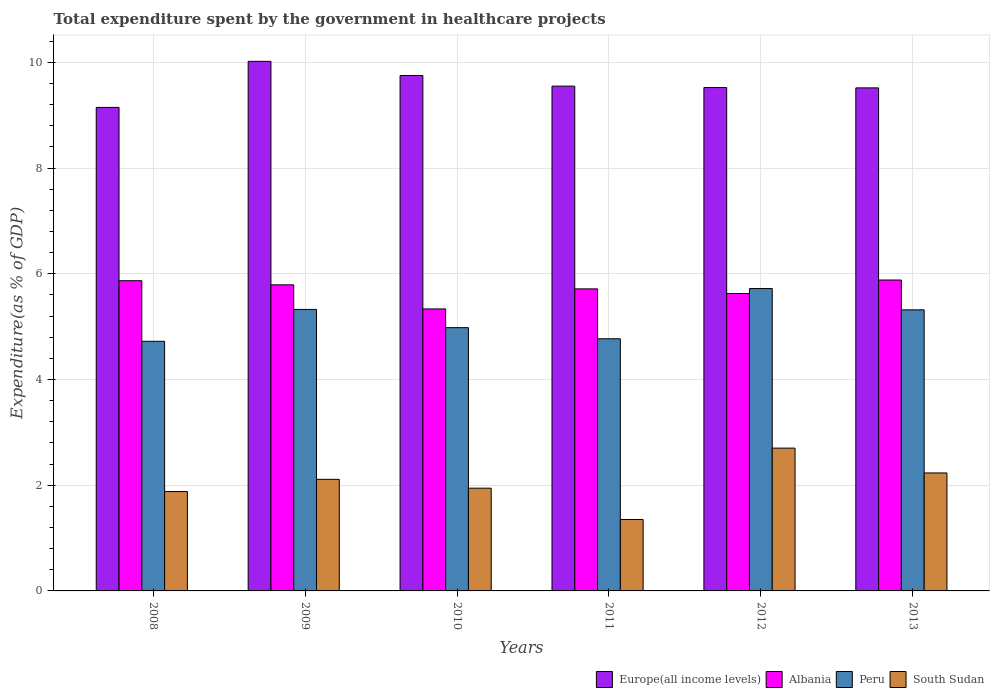Are the number of bars per tick equal to the number of legend labels?
Your response must be concise. Yes. Are the number of bars on each tick of the X-axis equal?
Ensure brevity in your answer.  Yes. How many bars are there on the 2nd tick from the left?
Offer a very short reply. 4. What is the total expenditure spent by the government in healthcare projects in Peru in 2011?
Provide a short and direct response. 4.77. Across all years, what is the maximum total expenditure spent by the government in healthcare projects in Peru?
Your answer should be very brief. 5.72. Across all years, what is the minimum total expenditure spent by the government in healthcare projects in Albania?
Make the answer very short. 5.34. In which year was the total expenditure spent by the government in healthcare projects in Peru maximum?
Your answer should be very brief. 2012. What is the total total expenditure spent by the government in healthcare projects in Albania in the graph?
Ensure brevity in your answer.  34.22. What is the difference between the total expenditure spent by the government in healthcare projects in South Sudan in 2008 and that in 2011?
Offer a terse response. 0.53. What is the difference between the total expenditure spent by the government in healthcare projects in South Sudan in 2008 and the total expenditure spent by the government in healthcare projects in Albania in 2009?
Make the answer very short. -3.91. What is the average total expenditure spent by the government in healthcare projects in Europe(all income levels) per year?
Keep it short and to the point. 9.59. In the year 2012, what is the difference between the total expenditure spent by the government in healthcare projects in Peru and total expenditure spent by the government in healthcare projects in Europe(all income levels)?
Give a very brief answer. -3.8. In how many years, is the total expenditure spent by the government in healthcare projects in Albania greater than 6.8 %?
Your answer should be very brief. 0. What is the ratio of the total expenditure spent by the government in healthcare projects in Europe(all income levels) in 2011 to that in 2013?
Make the answer very short. 1. Is the difference between the total expenditure spent by the government in healthcare projects in Peru in 2008 and 2011 greater than the difference between the total expenditure spent by the government in healthcare projects in Europe(all income levels) in 2008 and 2011?
Your response must be concise. Yes. What is the difference between the highest and the second highest total expenditure spent by the government in healthcare projects in Europe(all income levels)?
Offer a terse response. 0.27. What is the difference between the highest and the lowest total expenditure spent by the government in healthcare projects in Peru?
Keep it short and to the point. 1. Is the sum of the total expenditure spent by the government in healthcare projects in Albania in 2011 and 2012 greater than the maximum total expenditure spent by the government in healthcare projects in Europe(all income levels) across all years?
Your answer should be compact. Yes. What does the 2nd bar from the left in 2011 represents?
Keep it short and to the point. Albania. What does the 4th bar from the right in 2010 represents?
Provide a succinct answer. Europe(all income levels). How many bars are there?
Offer a very short reply. 24. What is the difference between two consecutive major ticks on the Y-axis?
Ensure brevity in your answer.  2. Are the values on the major ticks of Y-axis written in scientific E-notation?
Your response must be concise. No. Where does the legend appear in the graph?
Ensure brevity in your answer.  Bottom right. How are the legend labels stacked?
Your answer should be compact. Horizontal. What is the title of the graph?
Give a very brief answer. Total expenditure spent by the government in healthcare projects. What is the label or title of the X-axis?
Ensure brevity in your answer.  Years. What is the label or title of the Y-axis?
Offer a terse response. Expenditure(as % of GDP). What is the Expenditure(as % of GDP) of Europe(all income levels) in 2008?
Make the answer very short. 9.15. What is the Expenditure(as % of GDP) in Albania in 2008?
Your answer should be very brief. 5.87. What is the Expenditure(as % of GDP) in Peru in 2008?
Your answer should be compact. 4.72. What is the Expenditure(as % of GDP) in South Sudan in 2008?
Ensure brevity in your answer.  1.88. What is the Expenditure(as % of GDP) of Europe(all income levels) in 2009?
Your response must be concise. 10.02. What is the Expenditure(as % of GDP) in Albania in 2009?
Keep it short and to the point. 5.79. What is the Expenditure(as % of GDP) of Peru in 2009?
Your answer should be compact. 5.33. What is the Expenditure(as % of GDP) in South Sudan in 2009?
Make the answer very short. 2.11. What is the Expenditure(as % of GDP) of Europe(all income levels) in 2010?
Make the answer very short. 9.75. What is the Expenditure(as % of GDP) in Albania in 2010?
Your response must be concise. 5.34. What is the Expenditure(as % of GDP) of Peru in 2010?
Offer a very short reply. 4.98. What is the Expenditure(as % of GDP) of South Sudan in 2010?
Your response must be concise. 1.94. What is the Expenditure(as % of GDP) in Europe(all income levels) in 2011?
Ensure brevity in your answer.  9.55. What is the Expenditure(as % of GDP) of Albania in 2011?
Offer a very short reply. 5.71. What is the Expenditure(as % of GDP) of Peru in 2011?
Your answer should be very brief. 4.77. What is the Expenditure(as % of GDP) in South Sudan in 2011?
Offer a terse response. 1.35. What is the Expenditure(as % of GDP) of Europe(all income levels) in 2012?
Ensure brevity in your answer.  9.52. What is the Expenditure(as % of GDP) of Albania in 2012?
Give a very brief answer. 5.63. What is the Expenditure(as % of GDP) in Peru in 2012?
Provide a succinct answer. 5.72. What is the Expenditure(as % of GDP) in South Sudan in 2012?
Your answer should be very brief. 2.7. What is the Expenditure(as % of GDP) in Europe(all income levels) in 2013?
Provide a succinct answer. 9.52. What is the Expenditure(as % of GDP) in Albania in 2013?
Offer a very short reply. 5.88. What is the Expenditure(as % of GDP) of Peru in 2013?
Make the answer very short. 5.32. What is the Expenditure(as % of GDP) of South Sudan in 2013?
Provide a short and direct response. 2.23. Across all years, what is the maximum Expenditure(as % of GDP) in Europe(all income levels)?
Your answer should be compact. 10.02. Across all years, what is the maximum Expenditure(as % of GDP) in Albania?
Keep it short and to the point. 5.88. Across all years, what is the maximum Expenditure(as % of GDP) in Peru?
Ensure brevity in your answer.  5.72. Across all years, what is the maximum Expenditure(as % of GDP) in South Sudan?
Provide a short and direct response. 2.7. Across all years, what is the minimum Expenditure(as % of GDP) in Europe(all income levels)?
Your answer should be very brief. 9.15. Across all years, what is the minimum Expenditure(as % of GDP) of Albania?
Ensure brevity in your answer.  5.34. Across all years, what is the minimum Expenditure(as % of GDP) of Peru?
Provide a short and direct response. 4.72. Across all years, what is the minimum Expenditure(as % of GDP) in South Sudan?
Offer a terse response. 1.35. What is the total Expenditure(as % of GDP) of Europe(all income levels) in the graph?
Your answer should be very brief. 57.51. What is the total Expenditure(as % of GDP) of Albania in the graph?
Ensure brevity in your answer.  34.22. What is the total Expenditure(as % of GDP) in Peru in the graph?
Your answer should be compact. 30.84. What is the total Expenditure(as % of GDP) in South Sudan in the graph?
Your answer should be very brief. 12.22. What is the difference between the Expenditure(as % of GDP) in Europe(all income levels) in 2008 and that in 2009?
Provide a short and direct response. -0.87. What is the difference between the Expenditure(as % of GDP) of Albania in 2008 and that in 2009?
Offer a terse response. 0.08. What is the difference between the Expenditure(as % of GDP) of Peru in 2008 and that in 2009?
Keep it short and to the point. -0.6. What is the difference between the Expenditure(as % of GDP) in South Sudan in 2008 and that in 2009?
Give a very brief answer. -0.23. What is the difference between the Expenditure(as % of GDP) in Europe(all income levels) in 2008 and that in 2010?
Ensure brevity in your answer.  -0.6. What is the difference between the Expenditure(as % of GDP) of Albania in 2008 and that in 2010?
Keep it short and to the point. 0.53. What is the difference between the Expenditure(as % of GDP) of Peru in 2008 and that in 2010?
Keep it short and to the point. -0.26. What is the difference between the Expenditure(as % of GDP) in South Sudan in 2008 and that in 2010?
Provide a succinct answer. -0.06. What is the difference between the Expenditure(as % of GDP) in Europe(all income levels) in 2008 and that in 2011?
Ensure brevity in your answer.  -0.4. What is the difference between the Expenditure(as % of GDP) of Albania in 2008 and that in 2011?
Make the answer very short. 0.15. What is the difference between the Expenditure(as % of GDP) in Peru in 2008 and that in 2011?
Offer a terse response. -0.05. What is the difference between the Expenditure(as % of GDP) of South Sudan in 2008 and that in 2011?
Your response must be concise. 0.53. What is the difference between the Expenditure(as % of GDP) in Europe(all income levels) in 2008 and that in 2012?
Provide a short and direct response. -0.38. What is the difference between the Expenditure(as % of GDP) in Albania in 2008 and that in 2012?
Offer a terse response. 0.24. What is the difference between the Expenditure(as % of GDP) in Peru in 2008 and that in 2012?
Your response must be concise. -1. What is the difference between the Expenditure(as % of GDP) in South Sudan in 2008 and that in 2012?
Make the answer very short. -0.82. What is the difference between the Expenditure(as % of GDP) of Europe(all income levels) in 2008 and that in 2013?
Offer a very short reply. -0.37. What is the difference between the Expenditure(as % of GDP) in Albania in 2008 and that in 2013?
Keep it short and to the point. -0.01. What is the difference between the Expenditure(as % of GDP) of Peru in 2008 and that in 2013?
Keep it short and to the point. -0.59. What is the difference between the Expenditure(as % of GDP) in South Sudan in 2008 and that in 2013?
Offer a very short reply. -0.35. What is the difference between the Expenditure(as % of GDP) of Europe(all income levels) in 2009 and that in 2010?
Ensure brevity in your answer.  0.27. What is the difference between the Expenditure(as % of GDP) of Albania in 2009 and that in 2010?
Ensure brevity in your answer.  0.46. What is the difference between the Expenditure(as % of GDP) of Peru in 2009 and that in 2010?
Your answer should be very brief. 0.34. What is the difference between the Expenditure(as % of GDP) of South Sudan in 2009 and that in 2010?
Ensure brevity in your answer.  0.17. What is the difference between the Expenditure(as % of GDP) in Europe(all income levels) in 2009 and that in 2011?
Offer a terse response. 0.47. What is the difference between the Expenditure(as % of GDP) in Albania in 2009 and that in 2011?
Keep it short and to the point. 0.08. What is the difference between the Expenditure(as % of GDP) in Peru in 2009 and that in 2011?
Give a very brief answer. 0.56. What is the difference between the Expenditure(as % of GDP) of South Sudan in 2009 and that in 2011?
Your answer should be very brief. 0.76. What is the difference between the Expenditure(as % of GDP) of Europe(all income levels) in 2009 and that in 2012?
Give a very brief answer. 0.5. What is the difference between the Expenditure(as % of GDP) in Albania in 2009 and that in 2012?
Give a very brief answer. 0.16. What is the difference between the Expenditure(as % of GDP) of Peru in 2009 and that in 2012?
Your answer should be compact. -0.4. What is the difference between the Expenditure(as % of GDP) in South Sudan in 2009 and that in 2012?
Your response must be concise. -0.59. What is the difference between the Expenditure(as % of GDP) of Europe(all income levels) in 2009 and that in 2013?
Make the answer very short. 0.5. What is the difference between the Expenditure(as % of GDP) in Albania in 2009 and that in 2013?
Keep it short and to the point. -0.09. What is the difference between the Expenditure(as % of GDP) of Peru in 2009 and that in 2013?
Offer a terse response. 0.01. What is the difference between the Expenditure(as % of GDP) in South Sudan in 2009 and that in 2013?
Provide a succinct answer. -0.12. What is the difference between the Expenditure(as % of GDP) of Europe(all income levels) in 2010 and that in 2011?
Give a very brief answer. 0.2. What is the difference between the Expenditure(as % of GDP) of Albania in 2010 and that in 2011?
Your answer should be very brief. -0.38. What is the difference between the Expenditure(as % of GDP) in Peru in 2010 and that in 2011?
Offer a very short reply. 0.21. What is the difference between the Expenditure(as % of GDP) in South Sudan in 2010 and that in 2011?
Keep it short and to the point. 0.59. What is the difference between the Expenditure(as % of GDP) in Europe(all income levels) in 2010 and that in 2012?
Your response must be concise. 0.23. What is the difference between the Expenditure(as % of GDP) in Albania in 2010 and that in 2012?
Make the answer very short. -0.29. What is the difference between the Expenditure(as % of GDP) in Peru in 2010 and that in 2012?
Give a very brief answer. -0.74. What is the difference between the Expenditure(as % of GDP) in South Sudan in 2010 and that in 2012?
Your answer should be very brief. -0.76. What is the difference between the Expenditure(as % of GDP) of Europe(all income levels) in 2010 and that in 2013?
Provide a succinct answer. 0.23. What is the difference between the Expenditure(as % of GDP) in Albania in 2010 and that in 2013?
Your answer should be very brief. -0.55. What is the difference between the Expenditure(as % of GDP) of Peru in 2010 and that in 2013?
Provide a short and direct response. -0.34. What is the difference between the Expenditure(as % of GDP) of South Sudan in 2010 and that in 2013?
Make the answer very short. -0.29. What is the difference between the Expenditure(as % of GDP) in Europe(all income levels) in 2011 and that in 2012?
Your answer should be very brief. 0.03. What is the difference between the Expenditure(as % of GDP) of Albania in 2011 and that in 2012?
Provide a short and direct response. 0.09. What is the difference between the Expenditure(as % of GDP) in Peru in 2011 and that in 2012?
Offer a very short reply. -0.95. What is the difference between the Expenditure(as % of GDP) in South Sudan in 2011 and that in 2012?
Keep it short and to the point. -1.35. What is the difference between the Expenditure(as % of GDP) in Europe(all income levels) in 2011 and that in 2013?
Give a very brief answer. 0.03. What is the difference between the Expenditure(as % of GDP) of Albania in 2011 and that in 2013?
Your answer should be compact. -0.17. What is the difference between the Expenditure(as % of GDP) in Peru in 2011 and that in 2013?
Your answer should be very brief. -0.55. What is the difference between the Expenditure(as % of GDP) of South Sudan in 2011 and that in 2013?
Make the answer very short. -0.88. What is the difference between the Expenditure(as % of GDP) of Europe(all income levels) in 2012 and that in 2013?
Your answer should be very brief. 0.01. What is the difference between the Expenditure(as % of GDP) of Albania in 2012 and that in 2013?
Give a very brief answer. -0.25. What is the difference between the Expenditure(as % of GDP) in Peru in 2012 and that in 2013?
Offer a terse response. 0.4. What is the difference between the Expenditure(as % of GDP) of South Sudan in 2012 and that in 2013?
Ensure brevity in your answer.  0.47. What is the difference between the Expenditure(as % of GDP) in Europe(all income levels) in 2008 and the Expenditure(as % of GDP) in Albania in 2009?
Ensure brevity in your answer.  3.36. What is the difference between the Expenditure(as % of GDP) of Europe(all income levels) in 2008 and the Expenditure(as % of GDP) of Peru in 2009?
Provide a short and direct response. 3.82. What is the difference between the Expenditure(as % of GDP) in Europe(all income levels) in 2008 and the Expenditure(as % of GDP) in South Sudan in 2009?
Keep it short and to the point. 7.04. What is the difference between the Expenditure(as % of GDP) in Albania in 2008 and the Expenditure(as % of GDP) in Peru in 2009?
Your answer should be very brief. 0.54. What is the difference between the Expenditure(as % of GDP) in Albania in 2008 and the Expenditure(as % of GDP) in South Sudan in 2009?
Give a very brief answer. 3.76. What is the difference between the Expenditure(as % of GDP) in Peru in 2008 and the Expenditure(as % of GDP) in South Sudan in 2009?
Ensure brevity in your answer.  2.61. What is the difference between the Expenditure(as % of GDP) in Europe(all income levels) in 2008 and the Expenditure(as % of GDP) in Albania in 2010?
Your answer should be very brief. 3.81. What is the difference between the Expenditure(as % of GDP) in Europe(all income levels) in 2008 and the Expenditure(as % of GDP) in Peru in 2010?
Your answer should be compact. 4.17. What is the difference between the Expenditure(as % of GDP) in Europe(all income levels) in 2008 and the Expenditure(as % of GDP) in South Sudan in 2010?
Your answer should be compact. 7.2. What is the difference between the Expenditure(as % of GDP) of Albania in 2008 and the Expenditure(as % of GDP) of Peru in 2010?
Your answer should be compact. 0.89. What is the difference between the Expenditure(as % of GDP) in Albania in 2008 and the Expenditure(as % of GDP) in South Sudan in 2010?
Offer a very short reply. 3.93. What is the difference between the Expenditure(as % of GDP) of Peru in 2008 and the Expenditure(as % of GDP) of South Sudan in 2010?
Offer a terse response. 2.78. What is the difference between the Expenditure(as % of GDP) of Europe(all income levels) in 2008 and the Expenditure(as % of GDP) of Albania in 2011?
Keep it short and to the point. 3.43. What is the difference between the Expenditure(as % of GDP) in Europe(all income levels) in 2008 and the Expenditure(as % of GDP) in Peru in 2011?
Ensure brevity in your answer.  4.38. What is the difference between the Expenditure(as % of GDP) of Europe(all income levels) in 2008 and the Expenditure(as % of GDP) of South Sudan in 2011?
Provide a succinct answer. 7.8. What is the difference between the Expenditure(as % of GDP) in Albania in 2008 and the Expenditure(as % of GDP) in Peru in 2011?
Keep it short and to the point. 1.1. What is the difference between the Expenditure(as % of GDP) in Albania in 2008 and the Expenditure(as % of GDP) in South Sudan in 2011?
Your answer should be compact. 4.52. What is the difference between the Expenditure(as % of GDP) of Peru in 2008 and the Expenditure(as % of GDP) of South Sudan in 2011?
Make the answer very short. 3.37. What is the difference between the Expenditure(as % of GDP) in Europe(all income levels) in 2008 and the Expenditure(as % of GDP) in Albania in 2012?
Your answer should be very brief. 3.52. What is the difference between the Expenditure(as % of GDP) of Europe(all income levels) in 2008 and the Expenditure(as % of GDP) of Peru in 2012?
Your answer should be compact. 3.43. What is the difference between the Expenditure(as % of GDP) in Europe(all income levels) in 2008 and the Expenditure(as % of GDP) in South Sudan in 2012?
Provide a succinct answer. 6.45. What is the difference between the Expenditure(as % of GDP) in Albania in 2008 and the Expenditure(as % of GDP) in Peru in 2012?
Offer a very short reply. 0.15. What is the difference between the Expenditure(as % of GDP) in Albania in 2008 and the Expenditure(as % of GDP) in South Sudan in 2012?
Ensure brevity in your answer.  3.17. What is the difference between the Expenditure(as % of GDP) of Peru in 2008 and the Expenditure(as % of GDP) of South Sudan in 2012?
Give a very brief answer. 2.02. What is the difference between the Expenditure(as % of GDP) of Europe(all income levels) in 2008 and the Expenditure(as % of GDP) of Albania in 2013?
Your answer should be very brief. 3.27. What is the difference between the Expenditure(as % of GDP) in Europe(all income levels) in 2008 and the Expenditure(as % of GDP) in Peru in 2013?
Provide a succinct answer. 3.83. What is the difference between the Expenditure(as % of GDP) of Europe(all income levels) in 2008 and the Expenditure(as % of GDP) of South Sudan in 2013?
Your answer should be very brief. 6.92. What is the difference between the Expenditure(as % of GDP) of Albania in 2008 and the Expenditure(as % of GDP) of Peru in 2013?
Keep it short and to the point. 0.55. What is the difference between the Expenditure(as % of GDP) of Albania in 2008 and the Expenditure(as % of GDP) of South Sudan in 2013?
Your answer should be very brief. 3.64. What is the difference between the Expenditure(as % of GDP) of Peru in 2008 and the Expenditure(as % of GDP) of South Sudan in 2013?
Make the answer very short. 2.49. What is the difference between the Expenditure(as % of GDP) in Europe(all income levels) in 2009 and the Expenditure(as % of GDP) in Albania in 2010?
Offer a very short reply. 4.68. What is the difference between the Expenditure(as % of GDP) of Europe(all income levels) in 2009 and the Expenditure(as % of GDP) of Peru in 2010?
Give a very brief answer. 5.04. What is the difference between the Expenditure(as % of GDP) of Europe(all income levels) in 2009 and the Expenditure(as % of GDP) of South Sudan in 2010?
Offer a very short reply. 8.08. What is the difference between the Expenditure(as % of GDP) of Albania in 2009 and the Expenditure(as % of GDP) of Peru in 2010?
Offer a terse response. 0.81. What is the difference between the Expenditure(as % of GDP) in Albania in 2009 and the Expenditure(as % of GDP) in South Sudan in 2010?
Your answer should be very brief. 3.85. What is the difference between the Expenditure(as % of GDP) of Peru in 2009 and the Expenditure(as % of GDP) of South Sudan in 2010?
Provide a succinct answer. 3.38. What is the difference between the Expenditure(as % of GDP) in Europe(all income levels) in 2009 and the Expenditure(as % of GDP) in Albania in 2011?
Keep it short and to the point. 4.31. What is the difference between the Expenditure(as % of GDP) of Europe(all income levels) in 2009 and the Expenditure(as % of GDP) of Peru in 2011?
Provide a succinct answer. 5.25. What is the difference between the Expenditure(as % of GDP) in Europe(all income levels) in 2009 and the Expenditure(as % of GDP) in South Sudan in 2011?
Your response must be concise. 8.67. What is the difference between the Expenditure(as % of GDP) in Albania in 2009 and the Expenditure(as % of GDP) in Peru in 2011?
Offer a very short reply. 1.02. What is the difference between the Expenditure(as % of GDP) in Albania in 2009 and the Expenditure(as % of GDP) in South Sudan in 2011?
Offer a very short reply. 4.44. What is the difference between the Expenditure(as % of GDP) in Peru in 2009 and the Expenditure(as % of GDP) in South Sudan in 2011?
Your response must be concise. 3.97. What is the difference between the Expenditure(as % of GDP) in Europe(all income levels) in 2009 and the Expenditure(as % of GDP) in Albania in 2012?
Give a very brief answer. 4.39. What is the difference between the Expenditure(as % of GDP) of Europe(all income levels) in 2009 and the Expenditure(as % of GDP) of Peru in 2012?
Your response must be concise. 4.3. What is the difference between the Expenditure(as % of GDP) in Europe(all income levels) in 2009 and the Expenditure(as % of GDP) in South Sudan in 2012?
Your answer should be compact. 7.32. What is the difference between the Expenditure(as % of GDP) in Albania in 2009 and the Expenditure(as % of GDP) in Peru in 2012?
Give a very brief answer. 0.07. What is the difference between the Expenditure(as % of GDP) of Albania in 2009 and the Expenditure(as % of GDP) of South Sudan in 2012?
Offer a very short reply. 3.09. What is the difference between the Expenditure(as % of GDP) in Peru in 2009 and the Expenditure(as % of GDP) in South Sudan in 2012?
Offer a terse response. 2.62. What is the difference between the Expenditure(as % of GDP) of Europe(all income levels) in 2009 and the Expenditure(as % of GDP) of Albania in 2013?
Make the answer very short. 4.14. What is the difference between the Expenditure(as % of GDP) of Europe(all income levels) in 2009 and the Expenditure(as % of GDP) of Peru in 2013?
Provide a short and direct response. 4.7. What is the difference between the Expenditure(as % of GDP) of Europe(all income levels) in 2009 and the Expenditure(as % of GDP) of South Sudan in 2013?
Your answer should be very brief. 7.79. What is the difference between the Expenditure(as % of GDP) of Albania in 2009 and the Expenditure(as % of GDP) of Peru in 2013?
Ensure brevity in your answer.  0.47. What is the difference between the Expenditure(as % of GDP) of Albania in 2009 and the Expenditure(as % of GDP) of South Sudan in 2013?
Your answer should be compact. 3.56. What is the difference between the Expenditure(as % of GDP) of Peru in 2009 and the Expenditure(as % of GDP) of South Sudan in 2013?
Offer a terse response. 3.09. What is the difference between the Expenditure(as % of GDP) of Europe(all income levels) in 2010 and the Expenditure(as % of GDP) of Albania in 2011?
Your answer should be compact. 4.04. What is the difference between the Expenditure(as % of GDP) of Europe(all income levels) in 2010 and the Expenditure(as % of GDP) of Peru in 2011?
Keep it short and to the point. 4.98. What is the difference between the Expenditure(as % of GDP) of Europe(all income levels) in 2010 and the Expenditure(as % of GDP) of South Sudan in 2011?
Your response must be concise. 8.4. What is the difference between the Expenditure(as % of GDP) in Albania in 2010 and the Expenditure(as % of GDP) in Peru in 2011?
Offer a very short reply. 0.56. What is the difference between the Expenditure(as % of GDP) of Albania in 2010 and the Expenditure(as % of GDP) of South Sudan in 2011?
Make the answer very short. 3.98. What is the difference between the Expenditure(as % of GDP) of Peru in 2010 and the Expenditure(as % of GDP) of South Sudan in 2011?
Give a very brief answer. 3.63. What is the difference between the Expenditure(as % of GDP) of Europe(all income levels) in 2010 and the Expenditure(as % of GDP) of Albania in 2012?
Offer a terse response. 4.12. What is the difference between the Expenditure(as % of GDP) of Europe(all income levels) in 2010 and the Expenditure(as % of GDP) of Peru in 2012?
Your answer should be compact. 4.03. What is the difference between the Expenditure(as % of GDP) in Europe(all income levels) in 2010 and the Expenditure(as % of GDP) in South Sudan in 2012?
Your answer should be very brief. 7.05. What is the difference between the Expenditure(as % of GDP) in Albania in 2010 and the Expenditure(as % of GDP) in Peru in 2012?
Ensure brevity in your answer.  -0.39. What is the difference between the Expenditure(as % of GDP) in Albania in 2010 and the Expenditure(as % of GDP) in South Sudan in 2012?
Offer a very short reply. 2.63. What is the difference between the Expenditure(as % of GDP) in Peru in 2010 and the Expenditure(as % of GDP) in South Sudan in 2012?
Ensure brevity in your answer.  2.28. What is the difference between the Expenditure(as % of GDP) in Europe(all income levels) in 2010 and the Expenditure(as % of GDP) in Albania in 2013?
Provide a succinct answer. 3.87. What is the difference between the Expenditure(as % of GDP) of Europe(all income levels) in 2010 and the Expenditure(as % of GDP) of Peru in 2013?
Give a very brief answer. 4.43. What is the difference between the Expenditure(as % of GDP) in Europe(all income levels) in 2010 and the Expenditure(as % of GDP) in South Sudan in 2013?
Offer a very short reply. 7.52. What is the difference between the Expenditure(as % of GDP) of Albania in 2010 and the Expenditure(as % of GDP) of Peru in 2013?
Make the answer very short. 0.02. What is the difference between the Expenditure(as % of GDP) of Albania in 2010 and the Expenditure(as % of GDP) of South Sudan in 2013?
Your answer should be very brief. 3.1. What is the difference between the Expenditure(as % of GDP) of Peru in 2010 and the Expenditure(as % of GDP) of South Sudan in 2013?
Ensure brevity in your answer.  2.75. What is the difference between the Expenditure(as % of GDP) of Europe(all income levels) in 2011 and the Expenditure(as % of GDP) of Albania in 2012?
Offer a very short reply. 3.92. What is the difference between the Expenditure(as % of GDP) of Europe(all income levels) in 2011 and the Expenditure(as % of GDP) of Peru in 2012?
Keep it short and to the point. 3.83. What is the difference between the Expenditure(as % of GDP) in Europe(all income levels) in 2011 and the Expenditure(as % of GDP) in South Sudan in 2012?
Offer a very short reply. 6.85. What is the difference between the Expenditure(as % of GDP) in Albania in 2011 and the Expenditure(as % of GDP) in Peru in 2012?
Offer a terse response. -0.01. What is the difference between the Expenditure(as % of GDP) in Albania in 2011 and the Expenditure(as % of GDP) in South Sudan in 2012?
Provide a succinct answer. 3.01. What is the difference between the Expenditure(as % of GDP) in Peru in 2011 and the Expenditure(as % of GDP) in South Sudan in 2012?
Keep it short and to the point. 2.07. What is the difference between the Expenditure(as % of GDP) in Europe(all income levels) in 2011 and the Expenditure(as % of GDP) in Albania in 2013?
Keep it short and to the point. 3.67. What is the difference between the Expenditure(as % of GDP) of Europe(all income levels) in 2011 and the Expenditure(as % of GDP) of Peru in 2013?
Your answer should be compact. 4.23. What is the difference between the Expenditure(as % of GDP) in Europe(all income levels) in 2011 and the Expenditure(as % of GDP) in South Sudan in 2013?
Offer a very short reply. 7.32. What is the difference between the Expenditure(as % of GDP) in Albania in 2011 and the Expenditure(as % of GDP) in Peru in 2013?
Keep it short and to the point. 0.4. What is the difference between the Expenditure(as % of GDP) in Albania in 2011 and the Expenditure(as % of GDP) in South Sudan in 2013?
Your response must be concise. 3.48. What is the difference between the Expenditure(as % of GDP) in Peru in 2011 and the Expenditure(as % of GDP) in South Sudan in 2013?
Offer a terse response. 2.54. What is the difference between the Expenditure(as % of GDP) of Europe(all income levels) in 2012 and the Expenditure(as % of GDP) of Albania in 2013?
Give a very brief answer. 3.64. What is the difference between the Expenditure(as % of GDP) of Europe(all income levels) in 2012 and the Expenditure(as % of GDP) of Peru in 2013?
Your answer should be compact. 4.21. What is the difference between the Expenditure(as % of GDP) of Europe(all income levels) in 2012 and the Expenditure(as % of GDP) of South Sudan in 2013?
Your response must be concise. 7.29. What is the difference between the Expenditure(as % of GDP) in Albania in 2012 and the Expenditure(as % of GDP) in Peru in 2013?
Offer a terse response. 0.31. What is the difference between the Expenditure(as % of GDP) of Albania in 2012 and the Expenditure(as % of GDP) of South Sudan in 2013?
Offer a very short reply. 3.4. What is the difference between the Expenditure(as % of GDP) of Peru in 2012 and the Expenditure(as % of GDP) of South Sudan in 2013?
Make the answer very short. 3.49. What is the average Expenditure(as % of GDP) of Europe(all income levels) per year?
Offer a terse response. 9.59. What is the average Expenditure(as % of GDP) in Albania per year?
Offer a very short reply. 5.7. What is the average Expenditure(as % of GDP) of Peru per year?
Your response must be concise. 5.14. What is the average Expenditure(as % of GDP) in South Sudan per year?
Your answer should be compact. 2.04. In the year 2008, what is the difference between the Expenditure(as % of GDP) of Europe(all income levels) and Expenditure(as % of GDP) of Albania?
Offer a terse response. 3.28. In the year 2008, what is the difference between the Expenditure(as % of GDP) in Europe(all income levels) and Expenditure(as % of GDP) in Peru?
Provide a succinct answer. 4.43. In the year 2008, what is the difference between the Expenditure(as % of GDP) of Europe(all income levels) and Expenditure(as % of GDP) of South Sudan?
Provide a short and direct response. 7.27. In the year 2008, what is the difference between the Expenditure(as % of GDP) in Albania and Expenditure(as % of GDP) in Peru?
Ensure brevity in your answer.  1.15. In the year 2008, what is the difference between the Expenditure(as % of GDP) of Albania and Expenditure(as % of GDP) of South Sudan?
Give a very brief answer. 3.99. In the year 2008, what is the difference between the Expenditure(as % of GDP) of Peru and Expenditure(as % of GDP) of South Sudan?
Your answer should be very brief. 2.84. In the year 2009, what is the difference between the Expenditure(as % of GDP) in Europe(all income levels) and Expenditure(as % of GDP) in Albania?
Your response must be concise. 4.23. In the year 2009, what is the difference between the Expenditure(as % of GDP) in Europe(all income levels) and Expenditure(as % of GDP) in Peru?
Keep it short and to the point. 4.69. In the year 2009, what is the difference between the Expenditure(as % of GDP) in Europe(all income levels) and Expenditure(as % of GDP) in South Sudan?
Your response must be concise. 7.91. In the year 2009, what is the difference between the Expenditure(as % of GDP) in Albania and Expenditure(as % of GDP) in Peru?
Your answer should be compact. 0.47. In the year 2009, what is the difference between the Expenditure(as % of GDP) in Albania and Expenditure(as % of GDP) in South Sudan?
Provide a succinct answer. 3.68. In the year 2009, what is the difference between the Expenditure(as % of GDP) of Peru and Expenditure(as % of GDP) of South Sudan?
Provide a short and direct response. 3.21. In the year 2010, what is the difference between the Expenditure(as % of GDP) in Europe(all income levels) and Expenditure(as % of GDP) in Albania?
Your response must be concise. 4.42. In the year 2010, what is the difference between the Expenditure(as % of GDP) of Europe(all income levels) and Expenditure(as % of GDP) of Peru?
Your answer should be compact. 4.77. In the year 2010, what is the difference between the Expenditure(as % of GDP) in Europe(all income levels) and Expenditure(as % of GDP) in South Sudan?
Keep it short and to the point. 7.81. In the year 2010, what is the difference between the Expenditure(as % of GDP) of Albania and Expenditure(as % of GDP) of Peru?
Your answer should be very brief. 0.35. In the year 2010, what is the difference between the Expenditure(as % of GDP) in Albania and Expenditure(as % of GDP) in South Sudan?
Your answer should be very brief. 3.39. In the year 2010, what is the difference between the Expenditure(as % of GDP) in Peru and Expenditure(as % of GDP) in South Sudan?
Provide a succinct answer. 3.04. In the year 2011, what is the difference between the Expenditure(as % of GDP) of Europe(all income levels) and Expenditure(as % of GDP) of Albania?
Your answer should be compact. 3.84. In the year 2011, what is the difference between the Expenditure(as % of GDP) of Europe(all income levels) and Expenditure(as % of GDP) of Peru?
Your answer should be very brief. 4.78. In the year 2011, what is the difference between the Expenditure(as % of GDP) in Europe(all income levels) and Expenditure(as % of GDP) in South Sudan?
Your answer should be very brief. 8.2. In the year 2011, what is the difference between the Expenditure(as % of GDP) in Albania and Expenditure(as % of GDP) in Peru?
Your response must be concise. 0.94. In the year 2011, what is the difference between the Expenditure(as % of GDP) in Albania and Expenditure(as % of GDP) in South Sudan?
Provide a succinct answer. 4.36. In the year 2011, what is the difference between the Expenditure(as % of GDP) of Peru and Expenditure(as % of GDP) of South Sudan?
Offer a very short reply. 3.42. In the year 2012, what is the difference between the Expenditure(as % of GDP) of Europe(all income levels) and Expenditure(as % of GDP) of Albania?
Make the answer very short. 3.9. In the year 2012, what is the difference between the Expenditure(as % of GDP) in Europe(all income levels) and Expenditure(as % of GDP) in Peru?
Ensure brevity in your answer.  3.8. In the year 2012, what is the difference between the Expenditure(as % of GDP) in Europe(all income levels) and Expenditure(as % of GDP) in South Sudan?
Offer a very short reply. 6.82. In the year 2012, what is the difference between the Expenditure(as % of GDP) in Albania and Expenditure(as % of GDP) in Peru?
Make the answer very short. -0.09. In the year 2012, what is the difference between the Expenditure(as % of GDP) in Albania and Expenditure(as % of GDP) in South Sudan?
Keep it short and to the point. 2.93. In the year 2012, what is the difference between the Expenditure(as % of GDP) in Peru and Expenditure(as % of GDP) in South Sudan?
Your answer should be very brief. 3.02. In the year 2013, what is the difference between the Expenditure(as % of GDP) in Europe(all income levels) and Expenditure(as % of GDP) in Albania?
Offer a terse response. 3.64. In the year 2013, what is the difference between the Expenditure(as % of GDP) in Europe(all income levels) and Expenditure(as % of GDP) in Peru?
Your answer should be compact. 4.2. In the year 2013, what is the difference between the Expenditure(as % of GDP) in Europe(all income levels) and Expenditure(as % of GDP) in South Sudan?
Provide a succinct answer. 7.29. In the year 2013, what is the difference between the Expenditure(as % of GDP) of Albania and Expenditure(as % of GDP) of Peru?
Offer a terse response. 0.56. In the year 2013, what is the difference between the Expenditure(as % of GDP) in Albania and Expenditure(as % of GDP) in South Sudan?
Ensure brevity in your answer.  3.65. In the year 2013, what is the difference between the Expenditure(as % of GDP) in Peru and Expenditure(as % of GDP) in South Sudan?
Give a very brief answer. 3.09. What is the ratio of the Expenditure(as % of GDP) of Europe(all income levels) in 2008 to that in 2009?
Keep it short and to the point. 0.91. What is the ratio of the Expenditure(as % of GDP) in Albania in 2008 to that in 2009?
Your answer should be very brief. 1.01. What is the ratio of the Expenditure(as % of GDP) of Peru in 2008 to that in 2009?
Keep it short and to the point. 0.89. What is the ratio of the Expenditure(as % of GDP) of South Sudan in 2008 to that in 2009?
Your response must be concise. 0.89. What is the ratio of the Expenditure(as % of GDP) of Europe(all income levels) in 2008 to that in 2010?
Provide a succinct answer. 0.94. What is the ratio of the Expenditure(as % of GDP) in Albania in 2008 to that in 2010?
Offer a terse response. 1.1. What is the ratio of the Expenditure(as % of GDP) in Peru in 2008 to that in 2010?
Offer a very short reply. 0.95. What is the ratio of the Expenditure(as % of GDP) in South Sudan in 2008 to that in 2010?
Your answer should be very brief. 0.97. What is the ratio of the Expenditure(as % of GDP) in Europe(all income levels) in 2008 to that in 2011?
Ensure brevity in your answer.  0.96. What is the ratio of the Expenditure(as % of GDP) of Albania in 2008 to that in 2011?
Keep it short and to the point. 1.03. What is the ratio of the Expenditure(as % of GDP) of Peru in 2008 to that in 2011?
Your response must be concise. 0.99. What is the ratio of the Expenditure(as % of GDP) of South Sudan in 2008 to that in 2011?
Offer a very short reply. 1.39. What is the ratio of the Expenditure(as % of GDP) of Europe(all income levels) in 2008 to that in 2012?
Keep it short and to the point. 0.96. What is the ratio of the Expenditure(as % of GDP) in Albania in 2008 to that in 2012?
Give a very brief answer. 1.04. What is the ratio of the Expenditure(as % of GDP) in Peru in 2008 to that in 2012?
Offer a terse response. 0.83. What is the ratio of the Expenditure(as % of GDP) in South Sudan in 2008 to that in 2012?
Give a very brief answer. 0.7. What is the ratio of the Expenditure(as % of GDP) in Europe(all income levels) in 2008 to that in 2013?
Provide a short and direct response. 0.96. What is the ratio of the Expenditure(as % of GDP) of Albania in 2008 to that in 2013?
Provide a short and direct response. 1. What is the ratio of the Expenditure(as % of GDP) in Peru in 2008 to that in 2013?
Your answer should be compact. 0.89. What is the ratio of the Expenditure(as % of GDP) of South Sudan in 2008 to that in 2013?
Offer a terse response. 0.84. What is the ratio of the Expenditure(as % of GDP) in Europe(all income levels) in 2009 to that in 2010?
Provide a short and direct response. 1.03. What is the ratio of the Expenditure(as % of GDP) in Albania in 2009 to that in 2010?
Ensure brevity in your answer.  1.09. What is the ratio of the Expenditure(as % of GDP) in Peru in 2009 to that in 2010?
Your response must be concise. 1.07. What is the ratio of the Expenditure(as % of GDP) of South Sudan in 2009 to that in 2010?
Offer a terse response. 1.09. What is the ratio of the Expenditure(as % of GDP) in Europe(all income levels) in 2009 to that in 2011?
Provide a succinct answer. 1.05. What is the ratio of the Expenditure(as % of GDP) in Albania in 2009 to that in 2011?
Give a very brief answer. 1.01. What is the ratio of the Expenditure(as % of GDP) of Peru in 2009 to that in 2011?
Your answer should be compact. 1.12. What is the ratio of the Expenditure(as % of GDP) of South Sudan in 2009 to that in 2011?
Offer a terse response. 1.56. What is the ratio of the Expenditure(as % of GDP) of Europe(all income levels) in 2009 to that in 2012?
Provide a succinct answer. 1.05. What is the ratio of the Expenditure(as % of GDP) of Albania in 2009 to that in 2012?
Keep it short and to the point. 1.03. What is the ratio of the Expenditure(as % of GDP) of Peru in 2009 to that in 2012?
Your response must be concise. 0.93. What is the ratio of the Expenditure(as % of GDP) of South Sudan in 2009 to that in 2012?
Offer a terse response. 0.78. What is the ratio of the Expenditure(as % of GDP) in Europe(all income levels) in 2009 to that in 2013?
Make the answer very short. 1.05. What is the ratio of the Expenditure(as % of GDP) of Albania in 2009 to that in 2013?
Provide a succinct answer. 0.98. What is the ratio of the Expenditure(as % of GDP) in Peru in 2009 to that in 2013?
Ensure brevity in your answer.  1. What is the ratio of the Expenditure(as % of GDP) in South Sudan in 2009 to that in 2013?
Give a very brief answer. 0.95. What is the ratio of the Expenditure(as % of GDP) in Europe(all income levels) in 2010 to that in 2011?
Offer a very short reply. 1.02. What is the ratio of the Expenditure(as % of GDP) of Albania in 2010 to that in 2011?
Your answer should be compact. 0.93. What is the ratio of the Expenditure(as % of GDP) in Peru in 2010 to that in 2011?
Give a very brief answer. 1.04. What is the ratio of the Expenditure(as % of GDP) in South Sudan in 2010 to that in 2011?
Your answer should be compact. 1.44. What is the ratio of the Expenditure(as % of GDP) of Albania in 2010 to that in 2012?
Keep it short and to the point. 0.95. What is the ratio of the Expenditure(as % of GDP) in Peru in 2010 to that in 2012?
Offer a very short reply. 0.87. What is the ratio of the Expenditure(as % of GDP) in South Sudan in 2010 to that in 2012?
Provide a short and direct response. 0.72. What is the ratio of the Expenditure(as % of GDP) in Europe(all income levels) in 2010 to that in 2013?
Keep it short and to the point. 1.02. What is the ratio of the Expenditure(as % of GDP) in Albania in 2010 to that in 2013?
Offer a very short reply. 0.91. What is the ratio of the Expenditure(as % of GDP) of Peru in 2010 to that in 2013?
Provide a short and direct response. 0.94. What is the ratio of the Expenditure(as % of GDP) of South Sudan in 2010 to that in 2013?
Your answer should be very brief. 0.87. What is the ratio of the Expenditure(as % of GDP) of Albania in 2011 to that in 2012?
Make the answer very short. 1.02. What is the ratio of the Expenditure(as % of GDP) in Peru in 2011 to that in 2012?
Make the answer very short. 0.83. What is the ratio of the Expenditure(as % of GDP) in South Sudan in 2011 to that in 2012?
Your answer should be compact. 0.5. What is the ratio of the Expenditure(as % of GDP) in Albania in 2011 to that in 2013?
Your answer should be compact. 0.97. What is the ratio of the Expenditure(as % of GDP) in Peru in 2011 to that in 2013?
Give a very brief answer. 0.9. What is the ratio of the Expenditure(as % of GDP) in South Sudan in 2011 to that in 2013?
Your response must be concise. 0.61. What is the ratio of the Expenditure(as % of GDP) in Albania in 2012 to that in 2013?
Offer a terse response. 0.96. What is the ratio of the Expenditure(as % of GDP) in Peru in 2012 to that in 2013?
Ensure brevity in your answer.  1.08. What is the ratio of the Expenditure(as % of GDP) in South Sudan in 2012 to that in 2013?
Your answer should be very brief. 1.21. What is the difference between the highest and the second highest Expenditure(as % of GDP) of Europe(all income levels)?
Your answer should be compact. 0.27. What is the difference between the highest and the second highest Expenditure(as % of GDP) of Albania?
Keep it short and to the point. 0.01. What is the difference between the highest and the second highest Expenditure(as % of GDP) of Peru?
Make the answer very short. 0.4. What is the difference between the highest and the second highest Expenditure(as % of GDP) in South Sudan?
Provide a succinct answer. 0.47. What is the difference between the highest and the lowest Expenditure(as % of GDP) of Europe(all income levels)?
Keep it short and to the point. 0.87. What is the difference between the highest and the lowest Expenditure(as % of GDP) of Albania?
Make the answer very short. 0.55. What is the difference between the highest and the lowest Expenditure(as % of GDP) of Peru?
Your answer should be compact. 1. What is the difference between the highest and the lowest Expenditure(as % of GDP) of South Sudan?
Offer a very short reply. 1.35. 